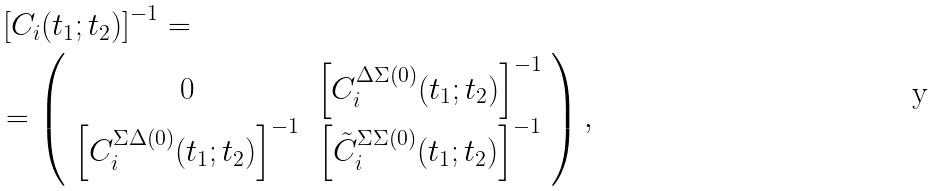<formula> <loc_0><loc_0><loc_500><loc_500>& \left [ { C } _ { i } ( t _ { 1 } ; t _ { 2 } ) \right ] ^ { - 1 } = \\ & = \left ( \begin{array} { c c } 0 & \left [ C _ { i } ^ { \Delta \Sigma ( 0 ) } ( t _ { 1 } ; t _ { 2 } ) \right ] ^ { - 1 } \\ \left [ C _ { i } ^ { \Sigma \Delta ( 0 ) } ( t _ { 1 } ; t _ { 2 } ) \right ] ^ { - 1 } & \left [ \tilde { C } _ { i } ^ { \Sigma \Sigma ( 0 ) } ( t _ { 1 } ; t _ { 2 } ) \right ] ^ { - 1 } \\ \end{array} \right ) ,</formula> 